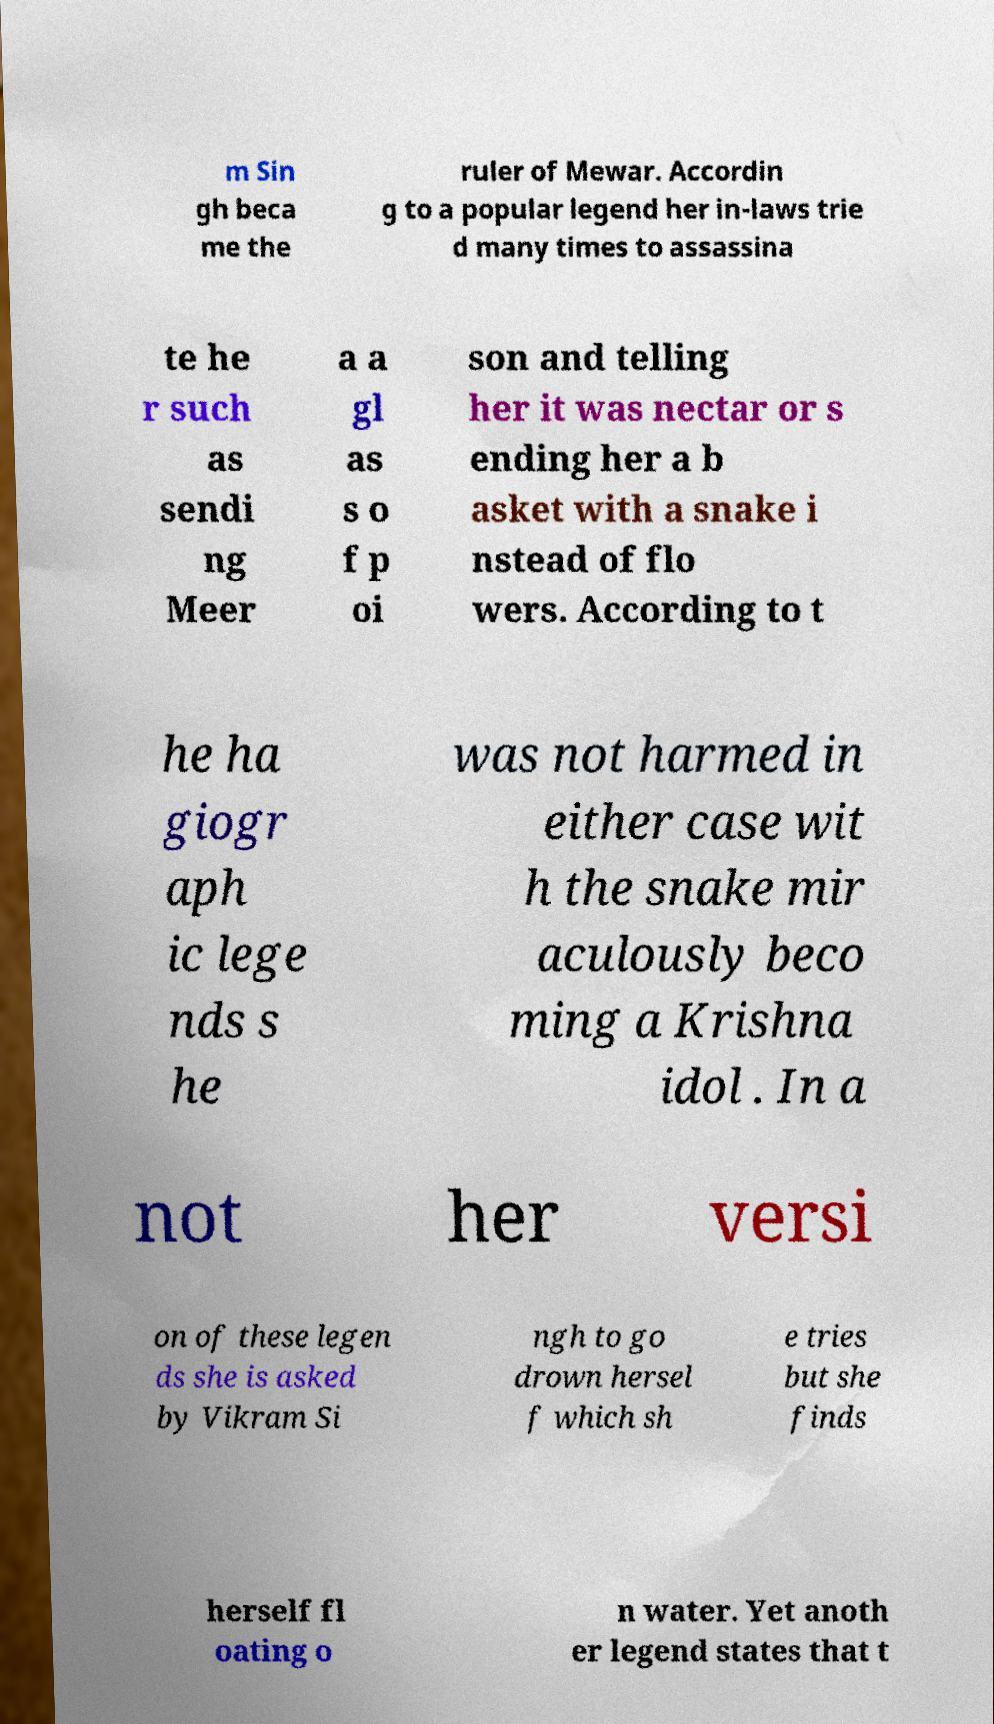Can you accurately transcribe the text from the provided image for me? m Sin gh beca me the ruler of Mewar. Accordin g to a popular legend her in-laws trie d many times to assassina te he r such as sendi ng Meer a a gl as s o f p oi son and telling her it was nectar or s ending her a b asket with a snake i nstead of flo wers. According to t he ha giogr aph ic lege nds s he was not harmed in either case wit h the snake mir aculously beco ming a Krishna idol . In a not her versi on of these legen ds she is asked by Vikram Si ngh to go drown hersel f which sh e tries but she finds herself fl oating o n water. Yet anoth er legend states that t 